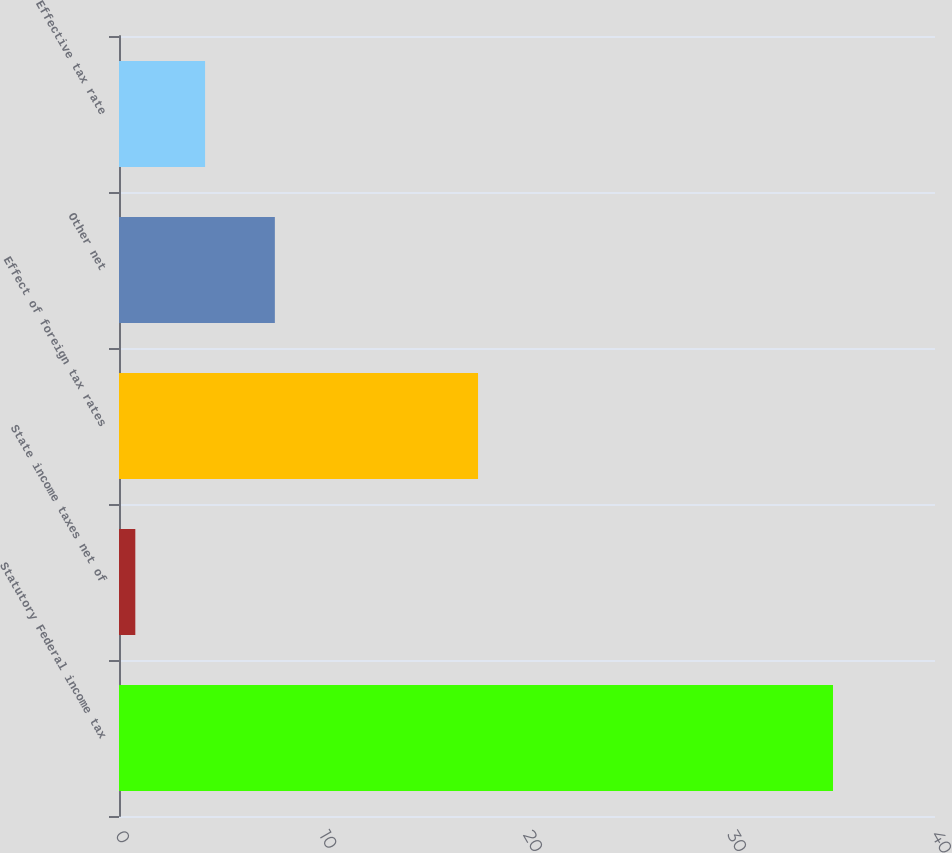Convert chart to OTSL. <chart><loc_0><loc_0><loc_500><loc_500><bar_chart><fcel>Statutory Federal income tax<fcel>State income taxes net of<fcel>Effect of foreign tax rates<fcel>Other net<fcel>Effective tax rate<nl><fcel>35<fcel>0.8<fcel>17.6<fcel>7.64<fcel>4.22<nl></chart> 